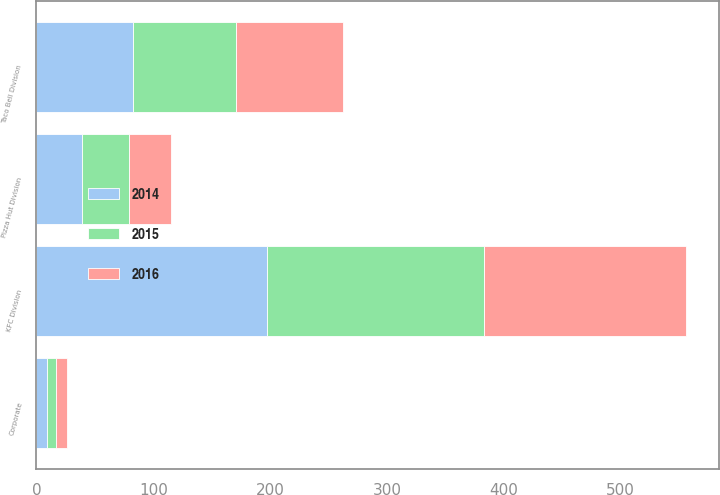Convert chart. <chart><loc_0><loc_0><loc_500><loc_500><stacked_bar_chart><ecel><fcel>KFC Division<fcel>Pizza Hut Division<fcel>Taco Bell Division<fcel>Corporate<nl><fcel>2016<fcel>173<fcel>36<fcel>91<fcel>9<nl><fcel>2015<fcel>186<fcel>40<fcel>88<fcel>8<nl><fcel>2014<fcel>197<fcel>39<fcel>83<fcel>9<nl></chart> 